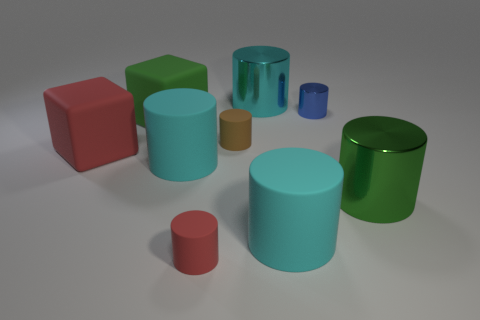How many cyan cylinders must be subtracted to get 1 cyan cylinders? 2 Subtract all cyan balls. How many cyan cylinders are left? 3 Subtract 3 cylinders. How many cylinders are left? 4 Subtract all red matte cylinders. How many cylinders are left? 6 Subtract all blue cylinders. How many cylinders are left? 6 Subtract all brown cylinders. Subtract all green balls. How many cylinders are left? 6 Subtract all blocks. How many objects are left? 7 Subtract all blue matte balls. Subtract all green cubes. How many objects are left? 8 Add 1 blue shiny cylinders. How many blue shiny cylinders are left? 2 Add 6 brown objects. How many brown objects exist? 7 